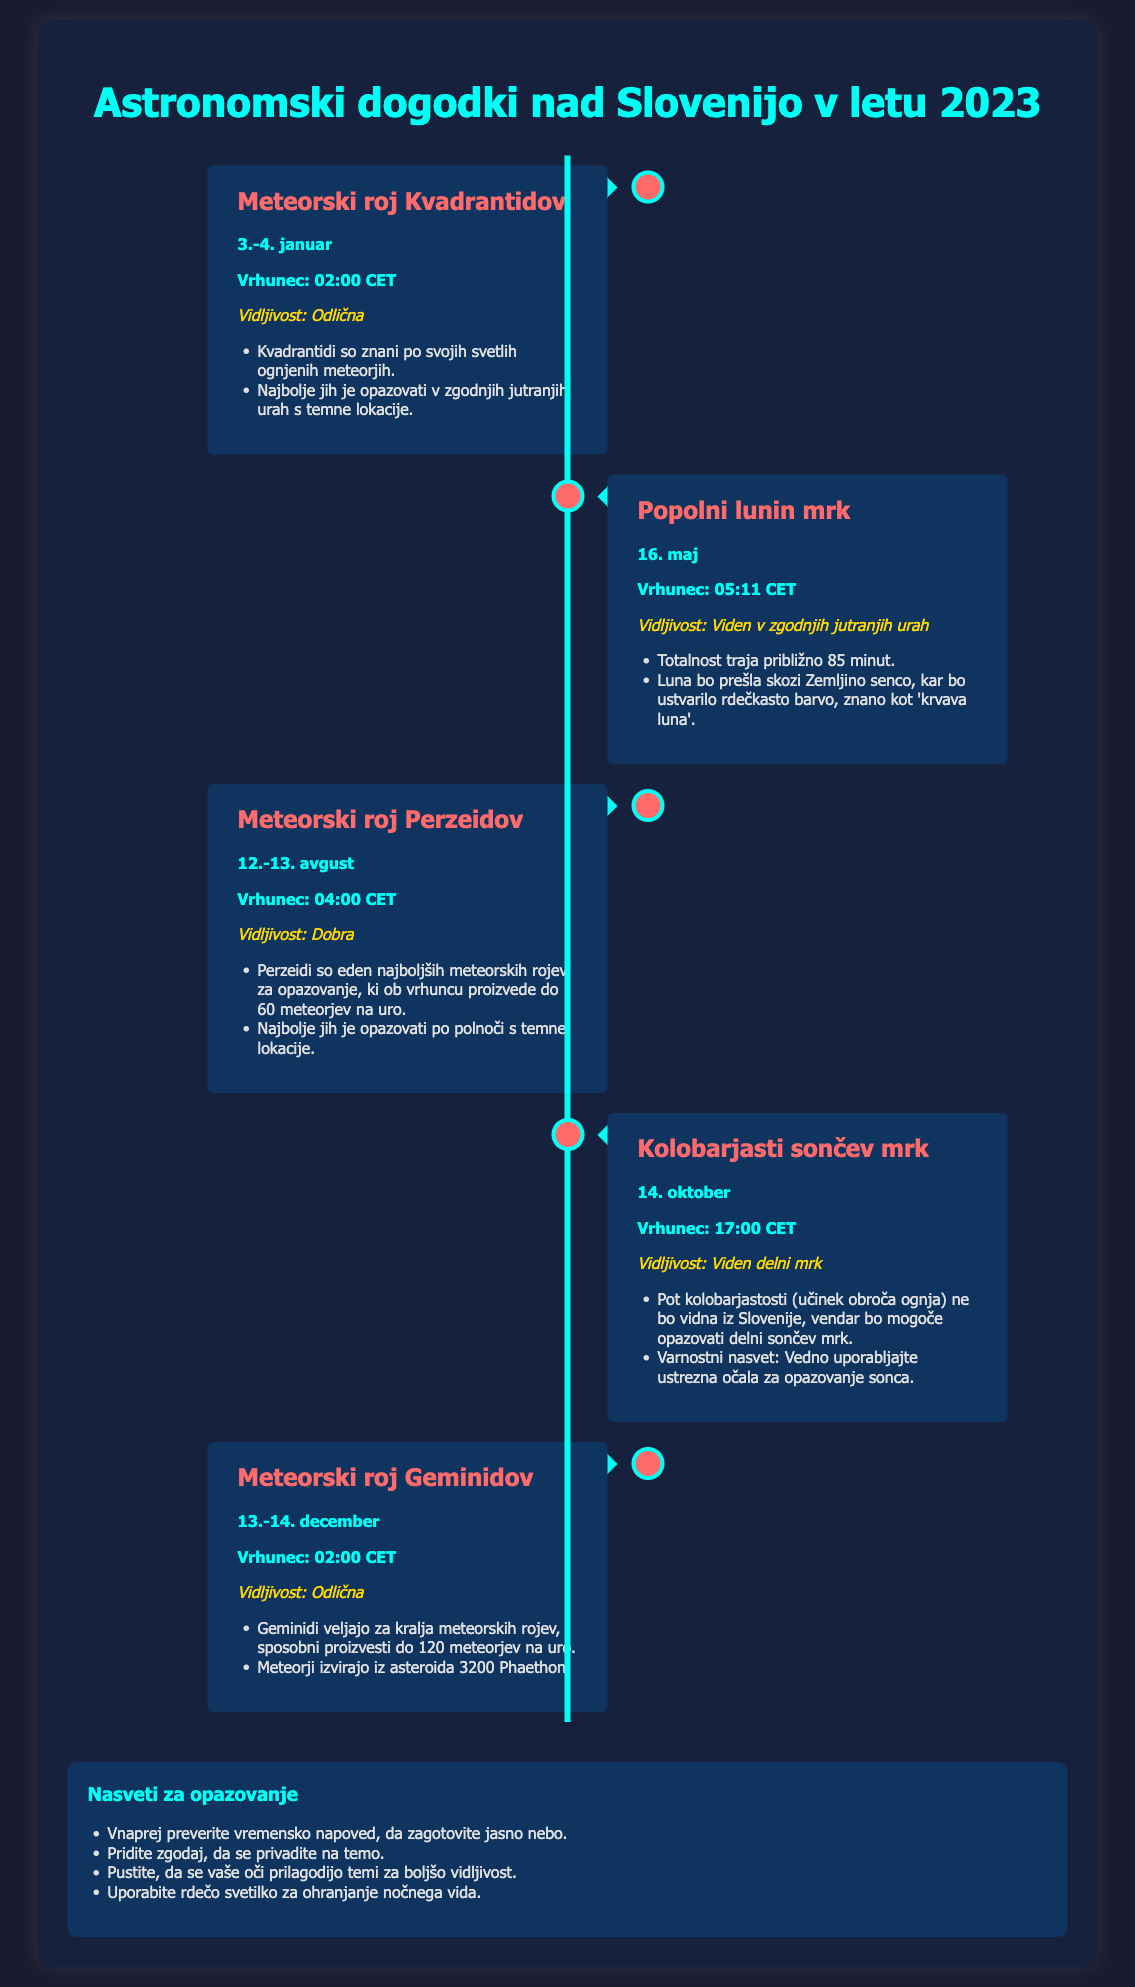what is the peak time for the Quadrantids meteor shower? The peak time for the Quadrantids meteor shower is mentioned in the document as 02:00 CET.
Answer: 02:00 CET when is the total lunar eclipse scheduled? The document states the total lunar eclipse is scheduled for May 16.
Answer: May 16 how many meteors can be observed per hour during the Geminids? The document indicates that the Geminids can produce up to 120 meteors per hour.
Answer: 120 what is the visibility status of the solar eclipse on October 14? The solar eclipse on October 14 is mentioned to have partial visibility.
Answer: Viden delni mrk which meteor shower occurs in August? The document lists the Perseids meteor shower occurring in August.
Answer: Perzeidi how long does the totality of the lunar eclipse last? The total duration of the totality of the lunar eclipse is approximately 85 minutes.
Answer: 85 minut what is a recommended tip for observing astronomical events? One of the tips provided in the document is to check the weather forecast in advance.
Answer: Preverite vremensko napoved where should one go to best observe the Quadrantids? The best observation location for the Quadrantids is a dark place, as mentioned in the document.
Answer: Temna lokacija 